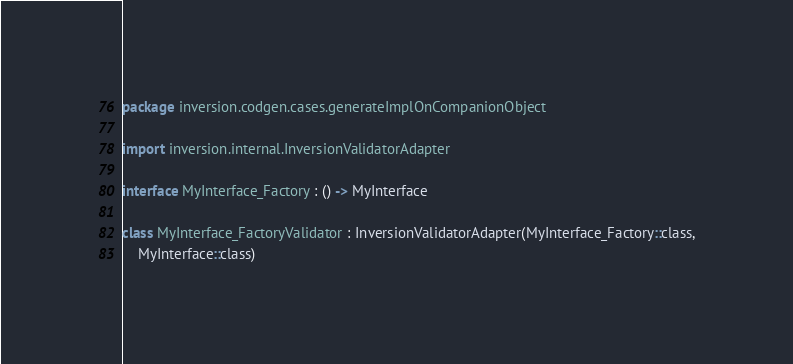<code> <loc_0><loc_0><loc_500><loc_500><_Kotlin_>package inversion.codgen.cases.generateImplOnCompanionObject

import inversion.internal.InversionValidatorAdapter

interface MyInterface_Factory : () -> MyInterface

class MyInterface_FactoryValidator : InversionValidatorAdapter(MyInterface_Factory::class,
    MyInterface::class)
</code> 